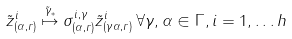Convert formula to latex. <formula><loc_0><loc_0><loc_500><loc_500>\tilde { z } ^ { i } _ { ( \alpha , r ) } \stackrel { \tilde { \gamma } _ { * } } { \mapsto } \sigma ^ { i , \gamma } _ { ( \alpha , r ) } \tilde { z } ^ { i } _ { ( \gamma \alpha , r ) } \, \forall \gamma , \alpha \in \Gamma , i = 1 , \dots h</formula> 